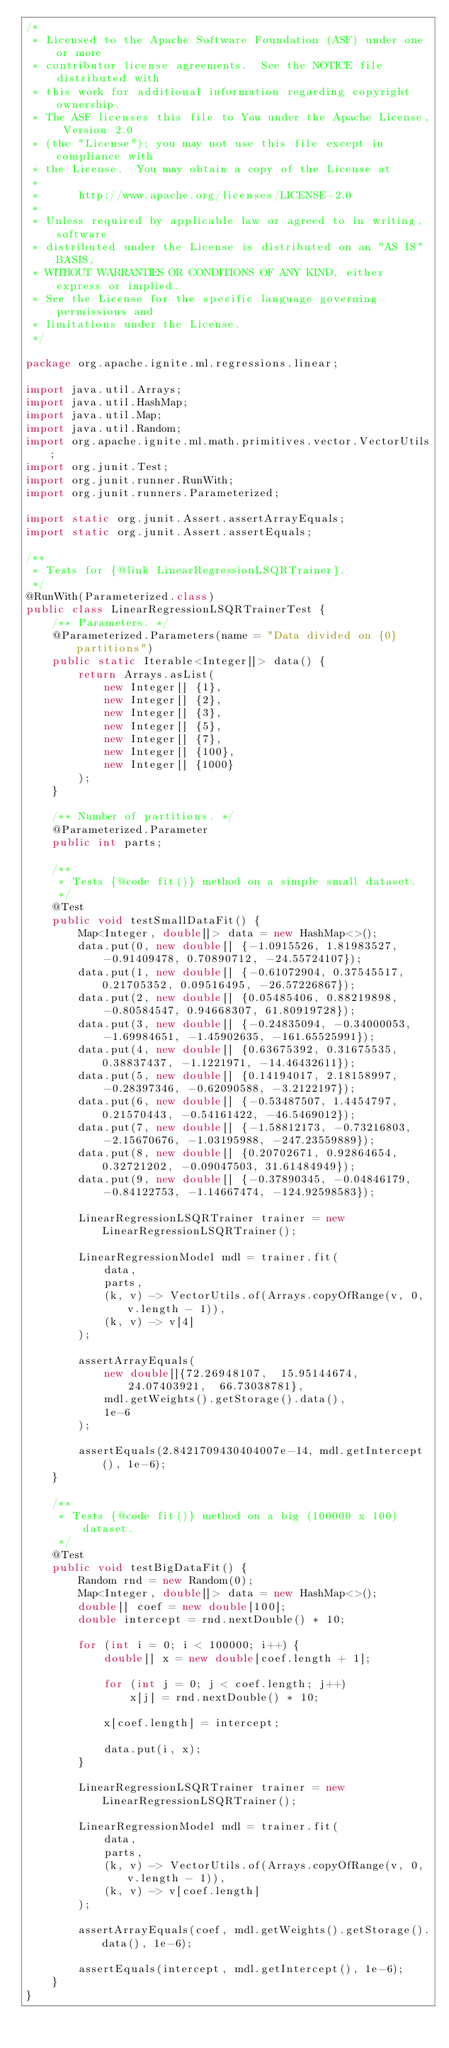Convert code to text. <code><loc_0><loc_0><loc_500><loc_500><_Java_>/*
 * Licensed to the Apache Software Foundation (ASF) under one or more
 * contributor license agreements.  See the NOTICE file distributed with
 * this work for additional information regarding copyright ownership.
 * The ASF licenses this file to You under the Apache License, Version 2.0
 * (the "License"); you may not use this file except in compliance with
 * the License.  You may obtain a copy of the License at
 *
 *      http://www.apache.org/licenses/LICENSE-2.0
 *
 * Unless required by applicable law or agreed to in writing, software
 * distributed under the License is distributed on an "AS IS" BASIS,
 * WITHOUT WARRANTIES OR CONDITIONS OF ANY KIND, either express or implied.
 * See the License for the specific language governing permissions and
 * limitations under the License.
 */

package org.apache.ignite.ml.regressions.linear;

import java.util.Arrays;
import java.util.HashMap;
import java.util.Map;
import java.util.Random;
import org.apache.ignite.ml.math.primitives.vector.VectorUtils;
import org.junit.Test;
import org.junit.runner.RunWith;
import org.junit.runners.Parameterized;

import static org.junit.Assert.assertArrayEquals;
import static org.junit.Assert.assertEquals;

/**
 * Tests for {@link LinearRegressionLSQRTrainer}.
 */
@RunWith(Parameterized.class)
public class LinearRegressionLSQRTrainerTest {
    /** Parameters. */
    @Parameterized.Parameters(name = "Data divided on {0} partitions")
    public static Iterable<Integer[]> data() {
        return Arrays.asList(
            new Integer[] {1},
            new Integer[] {2},
            new Integer[] {3},
            new Integer[] {5},
            new Integer[] {7},
            new Integer[] {100},
            new Integer[] {1000}
        );
    }

    /** Number of partitions. */
    @Parameterized.Parameter
    public int parts;

    /**
     * Tests {@code fit()} method on a simple small dataset.
     */
    @Test
    public void testSmallDataFit() {
        Map<Integer, double[]> data = new HashMap<>();
        data.put(0, new double[] {-1.0915526, 1.81983527, -0.91409478, 0.70890712, -24.55724107});
        data.put(1, new double[] {-0.61072904, 0.37545517, 0.21705352, 0.09516495, -26.57226867});
        data.put(2, new double[] {0.05485406, 0.88219898, -0.80584547, 0.94668307, 61.80919728});
        data.put(3, new double[] {-0.24835094, -0.34000053, -1.69984651, -1.45902635, -161.65525991});
        data.put(4, new double[] {0.63675392, 0.31675535, 0.38837437, -1.1221971, -14.46432611});
        data.put(5, new double[] {0.14194017, 2.18158997, -0.28397346, -0.62090588, -3.2122197});
        data.put(6, new double[] {-0.53487507, 1.4454797, 0.21570443, -0.54161422, -46.5469012});
        data.put(7, new double[] {-1.58812173, -0.73216803, -2.15670676, -1.03195988, -247.23559889});
        data.put(8, new double[] {0.20702671, 0.92864654, 0.32721202, -0.09047503, 31.61484949});
        data.put(9, new double[] {-0.37890345, -0.04846179, -0.84122753, -1.14667474, -124.92598583});

        LinearRegressionLSQRTrainer trainer = new LinearRegressionLSQRTrainer();

        LinearRegressionModel mdl = trainer.fit(
            data,
            parts,
            (k, v) -> VectorUtils.of(Arrays.copyOfRange(v, 0, v.length - 1)),
            (k, v) -> v[4]
        );

        assertArrayEquals(
            new double[]{72.26948107,  15.95144674,  24.07403921,  66.73038781},
            mdl.getWeights().getStorage().data(),
            1e-6
        );

        assertEquals(2.8421709430404007e-14, mdl.getIntercept(), 1e-6);
    }

    /**
     * Tests {@code fit()} method on a big (100000 x 100) dataset.
     */
    @Test
    public void testBigDataFit() {
        Random rnd = new Random(0);
        Map<Integer, double[]> data = new HashMap<>();
        double[] coef = new double[100];
        double intercept = rnd.nextDouble() * 10;

        for (int i = 0; i < 100000; i++) {
            double[] x = new double[coef.length + 1];

            for (int j = 0; j < coef.length; j++)
                x[j] = rnd.nextDouble() * 10;

            x[coef.length] = intercept;

            data.put(i, x);
        }

        LinearRegressionLSQRTrainer trainer = new LinearRegressionLSQRTrainer();

        LinearRegressionModel mdl = trainer.fit(
            data,
            parts,
            (k, v) -> VectorUtils.of(Arrays.copyOfRange(v, 0, v.length - 1)),
            (k, v) -> v[coef.length]
        );

        assertArrayEquals(coef, mdl.getWeights().getStorage().data(), 1e-6);

        assertEquals(intercept, mdl.getIntercept(), 1e-6);
    }
}
</code> 